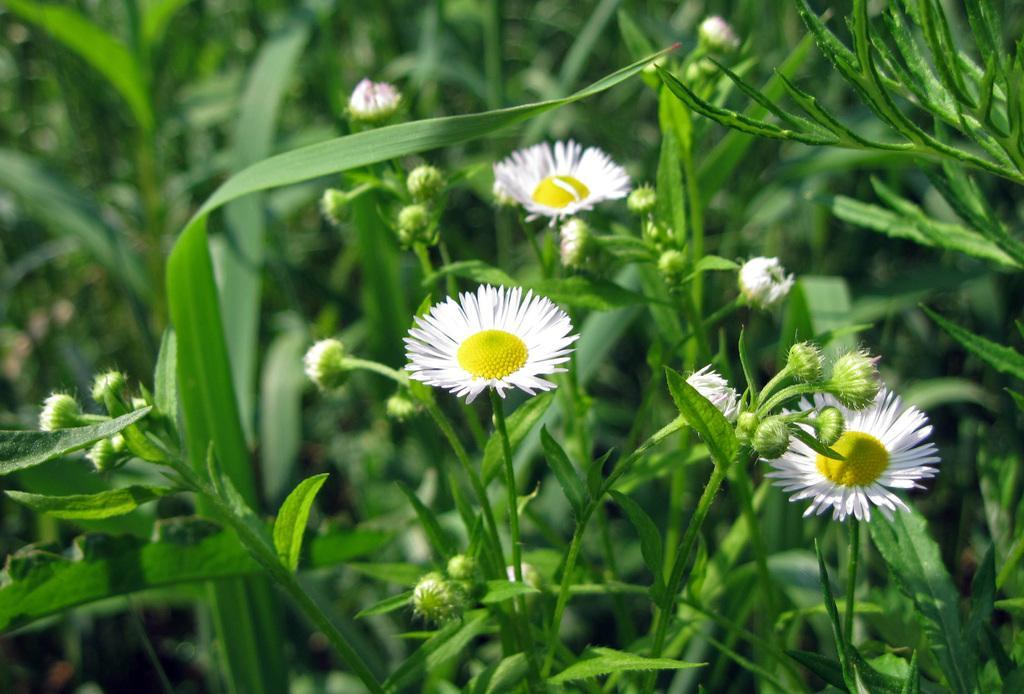In one or two sentences, can you explain what this image depicts? Here in this picture we can see flowers present on plants. 